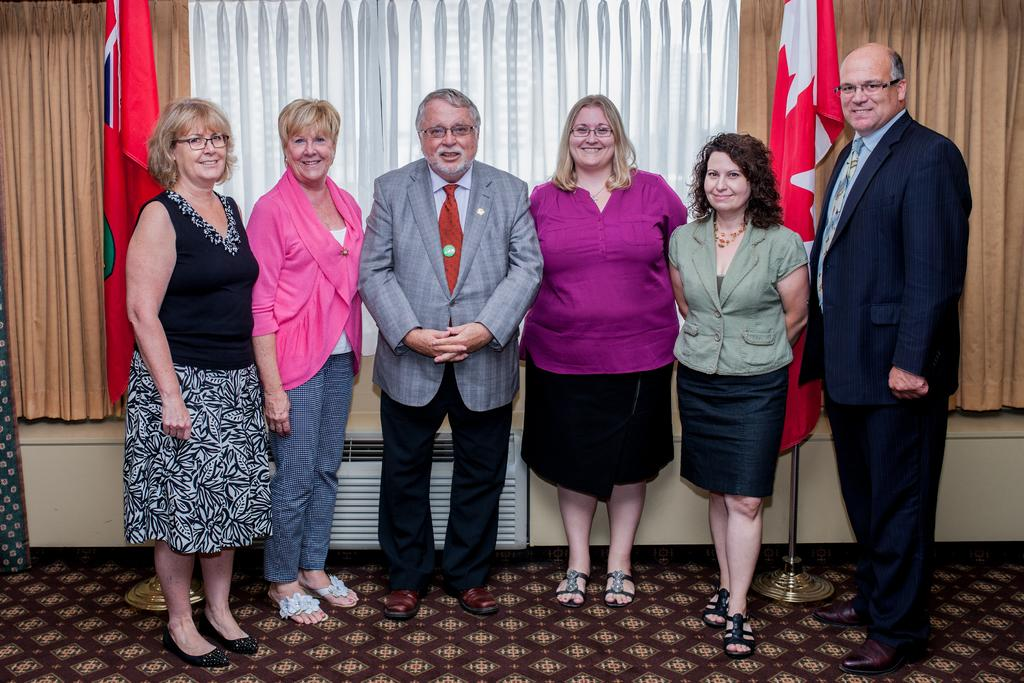How many people are in the image? There are six persons in the image. What can be observed about the attire of the persons? The persons are wearing different color dresses. What is the facial expression of the persons? The persons are smiling. Where are the persons standing? The persons are standing on the floor. What can be seen in the background of the image? There are two flags and curtains in the background of the image. What type of iron can be seen in the image? There is no iron present in the image. What message of peace is being conveyed by the persons in the image? The image does not convey a specific message of peace; it simply shows six persons wearing different color dresses and smiling. 